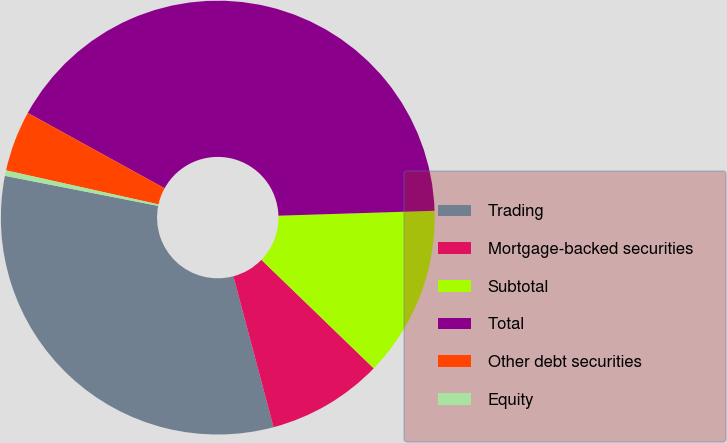Convert chart. <chart><loc_0><loc_0><loc_500><loc_500><pie_chart><fcel>Trading<fcel>Mortgage-backed securities<fcel>Subtotal<fcel>Total<fcel>Other debt securities<fcel>Equity<nl><fcel>32.23%<fcel>8.63%<fcel>12.73%<fcel>41.49%<fcel>4.52%<fcel>0.41%<nl></chart> 